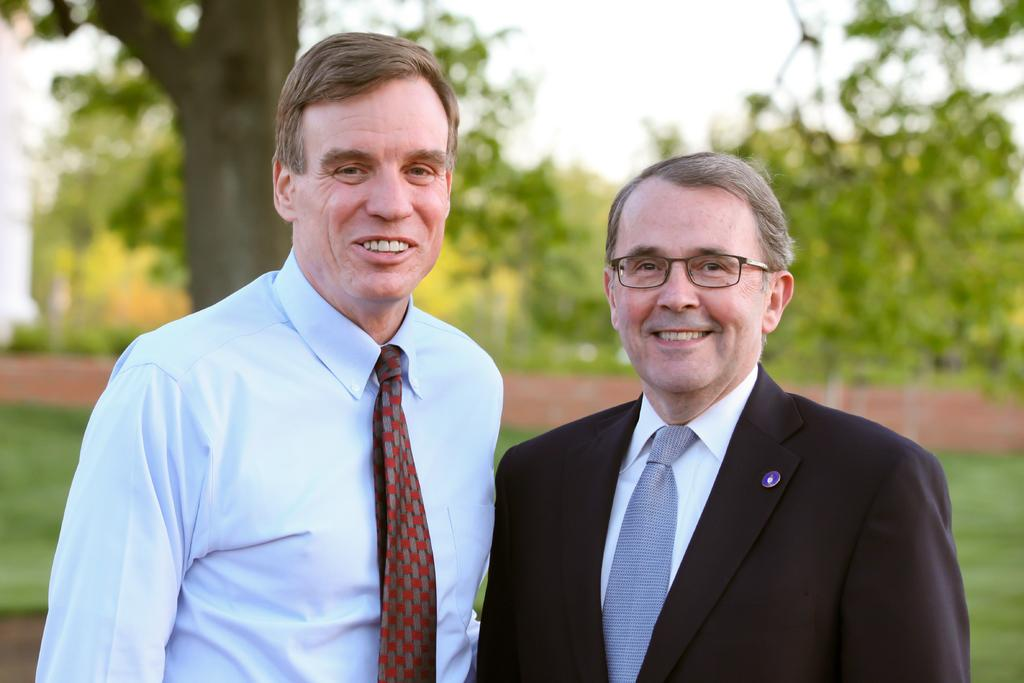How many people are present in the image? There are two men in the image. What can be seen in the background of the image? There are trees and the sky visible in the background of the image. What type of vegetable is being offered by one of the men in the image? There is: There is no vegetable present in the image, nor is anyone offering anything. 